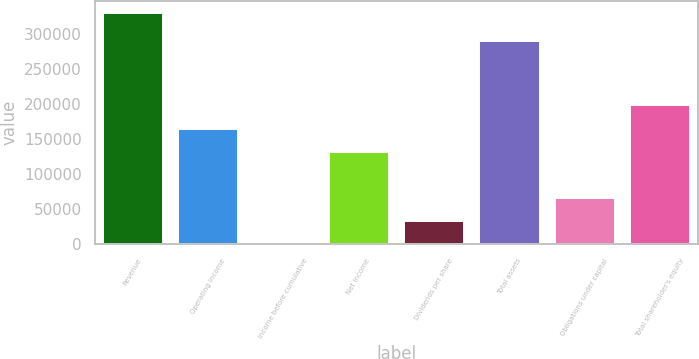<chart> <loc_0><loc_0><loc_500><loc_500><bar_chart><fcel>Revenue<fcel>Operating income<fcel>Income before cumulative<fcel>Net income<fcel>Dividends per share<fcel>Total assets<fcel>Obligations under capital<fcel>Total shareholder's equity<nl><fcel>330051<fcel>165026<fcel>1.53<fcel>132021<fcel>33006.5<fcel>289667<fcel>66011.4<fcel>198031<nl></chart> 